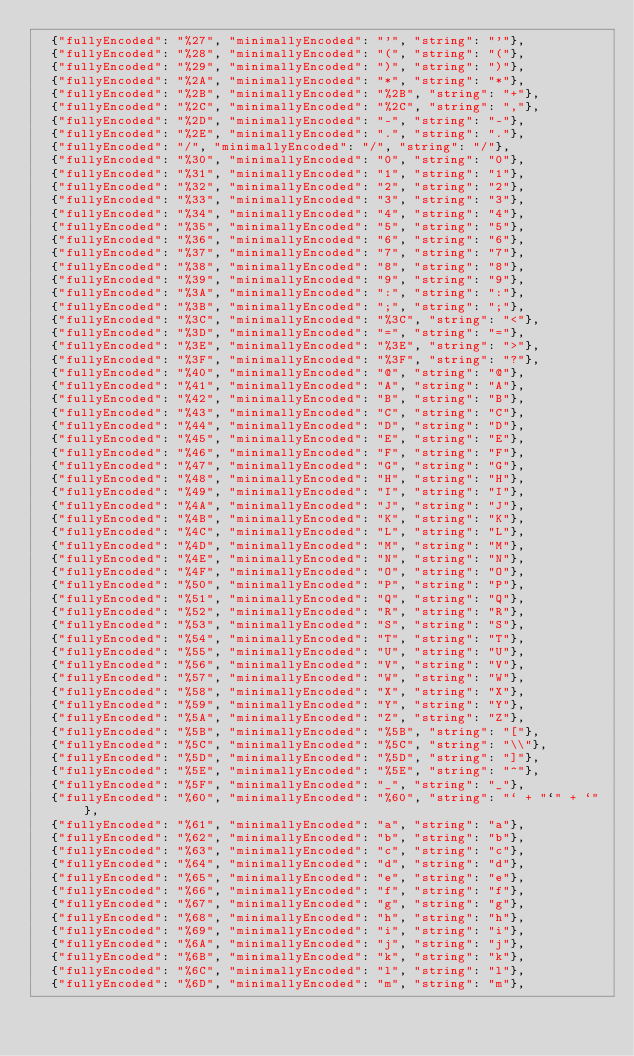Convert code to text. <code><loc_0><loc_0><loc_500><loc_500><_Go_>  {"fullyEncoded": "%27", "minimallyEncoded": "'", "string": "'"},
  {"fullyEncoded": "%28", "minimallyEncoded": "(", "string": "("},
  {"fullyEncoded": "%29", "minimallyEncoded": ")", "string": ")"},
  {"fullyEncoded": "%2A", "minimallyEncoded": "*", "string": "*"},
  {"fullyEncoded": "%2B", "minimallyEncoded": "%2B", "string": "+"},
  {"fullyEncoded": "%2C", "minimallyEncoded": "%2C", "string": ","},
  {"fullyEncoded": "%2D", "minimallyEncoded": "-", "string": "-"},
  {"fullyEncoded": "%2E", "minimallyEncoded": ".", "string": "."},
  {"fullyEncoded": "/", "minimallyEncoded": "/", "string": "/"},
  {"fullyEncoded": "%30", "minimallyEncoded": "0", "string": "0"},
  {"fullyEncoded": "%31", "minimallyEncoded": "1", "string": "1"},
  {"fullyEncoded": "%32", "minimallyEncoded": "2", "string": "2"},
  {"fullyEncoded": "%33", "minimallyEncoded": "3", "string": "3"},
  {"fullyEncoded": "%34", "minimallyEncoded": "4", "string": "4"},
  {"fullyEncoded": "%35", "minimallyEncoded": "5", "string": "5"},
  {"fullyEncoded": "%36", "minimallyEncoded": "6", "string": "6"},
  {"fullyEncoded": "%37", "minimallyEncoded": "7", "string": "7"},
  {"fullyEncoded": "%38", "minimallyEncoded": "8", "string": "8"},
  {"fullyEncoded": "%39", "minimallyEncoded": "9", "string": "9"},
  {"fullyEncoded": "%3A", "minimallyEncoded": ":", "string": ":"},
  {"fullyEncoded": "%3B", "minimallyEncoded": ";", "string": ";"},
  {"fullyEncoded": "%3C", "minimallyEncoded": "%3C", "string": "<"},
  {"fullyEncoded": "%3D", "minimallyEncoded": "=", "string": "="},
  {"fullyEncoded": "%3E", "minimallyEncoded": "%3E", "string": ">"},
  {"fullyEncoded": "%3F", "minimallyEncoded": "%3F", "string": "?"},
  {"fullyEncoded": "%40", "minimallyEncoded": "@", "string": "@"},
  {"fullyEncoded": "%41", "minimallyEncoded": "A", "string": "A"},
  {"fullyEncoded": "%42", "minimallyEncoded": "B", "string": "B"},
  {"fullyEncoded": "%43", "minimallyEncoded": "C", "string": "C"},
  {"fullyEncoded": "%44", "minimallyEncoded": "D", "string": "D"},
  {"fullyEncoded": "%45", "minimallyEncoded": "E", "string": "E"},
  {"fullyEncoded": "%46", "minimallyEncoded": "F", "string": "F"},
  {"fullyEncoded": "%47", "minimallyEncoded": "G", "string": "G"},
  {"fullyEncoded": "%48", "minimallyEncoded": "H", "string": "H"},
  {"fullyEncoded": "%49", "minimallyEncoded": "I", "string": "I"},
  {"fullyEncoded": "%4A", "minimallyEncoded": "J", "string": "J"},
  {"fullyEncoded": "%4B", "minimallyEncoded": "K", "string": "K"},
  {"fullyEncoded": "%4C", "minimallyEncoded": "L", "string": "L"},
  {"fullyEncoded": "%4D", "minimallyEncoded": "M", "string": "M"},
  {"fullyEncoded": "%4E", "minimallyEncoded": "N", "string": "N"},
  {"fullyEncoded": "%4F", "minimallyEncoded": "O", "string": "O"},
  {"fullyEncoded": "%50", "minimallyEncoded": "P", "string": "P"},
  {"fullyEncoded": "%51", "minimallyEncoded": "Q", "string": "Q"},
  {"fullyEncoded": "%52", "minimallyEncoded": "R", "string": "R"},
  {"fullyEncoded": "%53", "minimallyEncoded": "S", "string": "S"},
  {"fullyEncoded": "%54", "minimallyEncoded": "T", "string": "T"},
  {"fullyEncoded": "%55", "minimallyEncoded": "U", "string": "U"},
  {"fullyEncoded": "%56", "minimallyEncoded": "V", "string": "V"},
  {"fullyEncoded": "%57", "minimallyEncoded": "W", "string": "W"},
  {"fullyEncoded": "%58", "minimallyEncoded": "X", "string": "X"},
  {"fullyEncoded": "%59", "minimallyEncoded": "Y", "string": "Y"},
  {"fullyEncoded": "%5A", "minimallyEncoded": "Z", "string": "Z"},
  {"fullyEncoded": "%5B", "minimallyEncoded": "%5B", "string": "["},
  {"fullyEncoded": "%5C", "minimallyEncoded": "%5C", "string": "\\"},
  {"fullyEncoded": "%5D", "minimallyEncoded": "%5D", "string": "]"},
  {"fullyEncoded": "%5E", "minimallyEncoded": "%5E", "string": "^"},
  {"fullyEncoded": "%5F", "minimallyEncoded": "_", "string": "_"},
  {"fullyEncoded": "%60", "minimallyEncoded": "%60", "string": "` + "`" + `"},
  {"fullyEncoded": "%61", "minimallyEncoded": "a", "string": "a"},
  {"fullyEncoded": "%62", "minimallyEncoded": "b", "string": "b"},
  {"fullyEncoded": "%63", "minimallyEncoded": "c", "string": "c"},
  {"fullyEncoded": "%64", "minimallyEncoded": "d", "string": "d"},
  {"fullyEncoded": "%65", "minimallyEncoded": "e", "string": "e"},
  {"fullyEncoded": "%66", "minimallyEncoded": "f", "string": "f"},
  {"fullyEncoded": "%67", "minimallyEncoded": "g", "string": "g"},
  {"fullyEncoded": "%68", "minimallyEncoded": "h", "string": "h"},
  {"fullyEncoded": "%69", "minimallyEncoded": "i", "string": "i"},
  {"fullyEncoded": "%6A", "minimallyEncoded": "j", "string": "j"},
  {"fullyEncoded": "%6B", "minimallyEncoded": "k", "string": "k"},
  {"fullyEncoded": "%6C", "minimallyEncoded": "l", "string": "l"},
  {"fullyEncoded": "%6D", "minimallyEncoded": "m", "string": "m"},</code> 